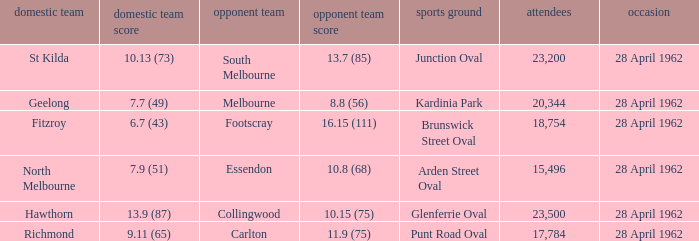What away team played at Brunswick Street Oval? Footscray. 